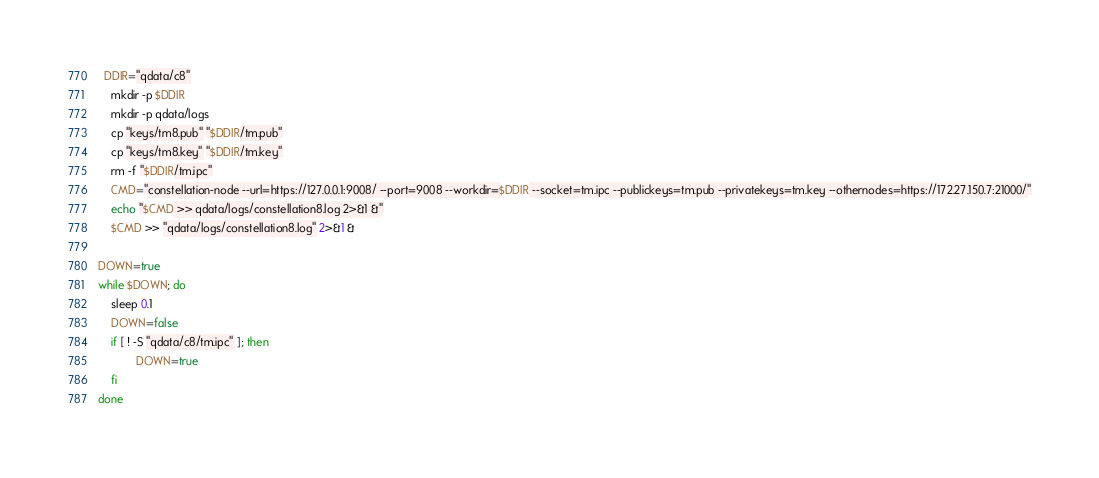Convert code to text. <code><loc_0><loc_0><loc_500><loc_500><_Bash_>  DDIR="qdata/c8"
    mkdir -p $DDIR
    mkdir -p qdata/logs
    cp "keys/tm8.pub" "$DDIR/tm.pub"
    cp "keys/tm8.key" "$DDIR/tm.key"
    rm -f "$DDIR/tm.ipc"
    CMD="constellation-node --url=https://127.0.0.1:9008/ --port=9008 --workdir=$DDIR --socket=tm.ipc --publickeys=tm.pub --privatekeys=tm.key --othernodes=https://172.27.150.7:21000/"
    echo "$CMD >> qdata/logs/constellation8.log 2>&1 &"
    $CMD >> "qdata/logs/constellation8.log" 2>&1 &

DOWN=true
while $DOWN; do
    sleep 0.1
    DOWN=false
 	if [ ! -S "qdata/c8/tm.ipc" ]; then
            DOWN=true
	fi
done
</code> 